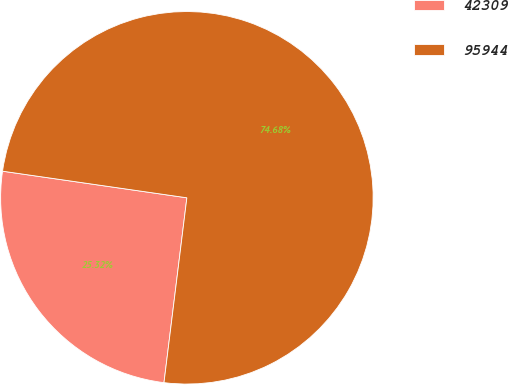Convert chart. <chart><loc_0><loc_0><loc_500><loc_500><pie_chart><fcel>42309<fcel>95944<nl><fcel>25.32%<fcel>74.68%<nl></chart> 